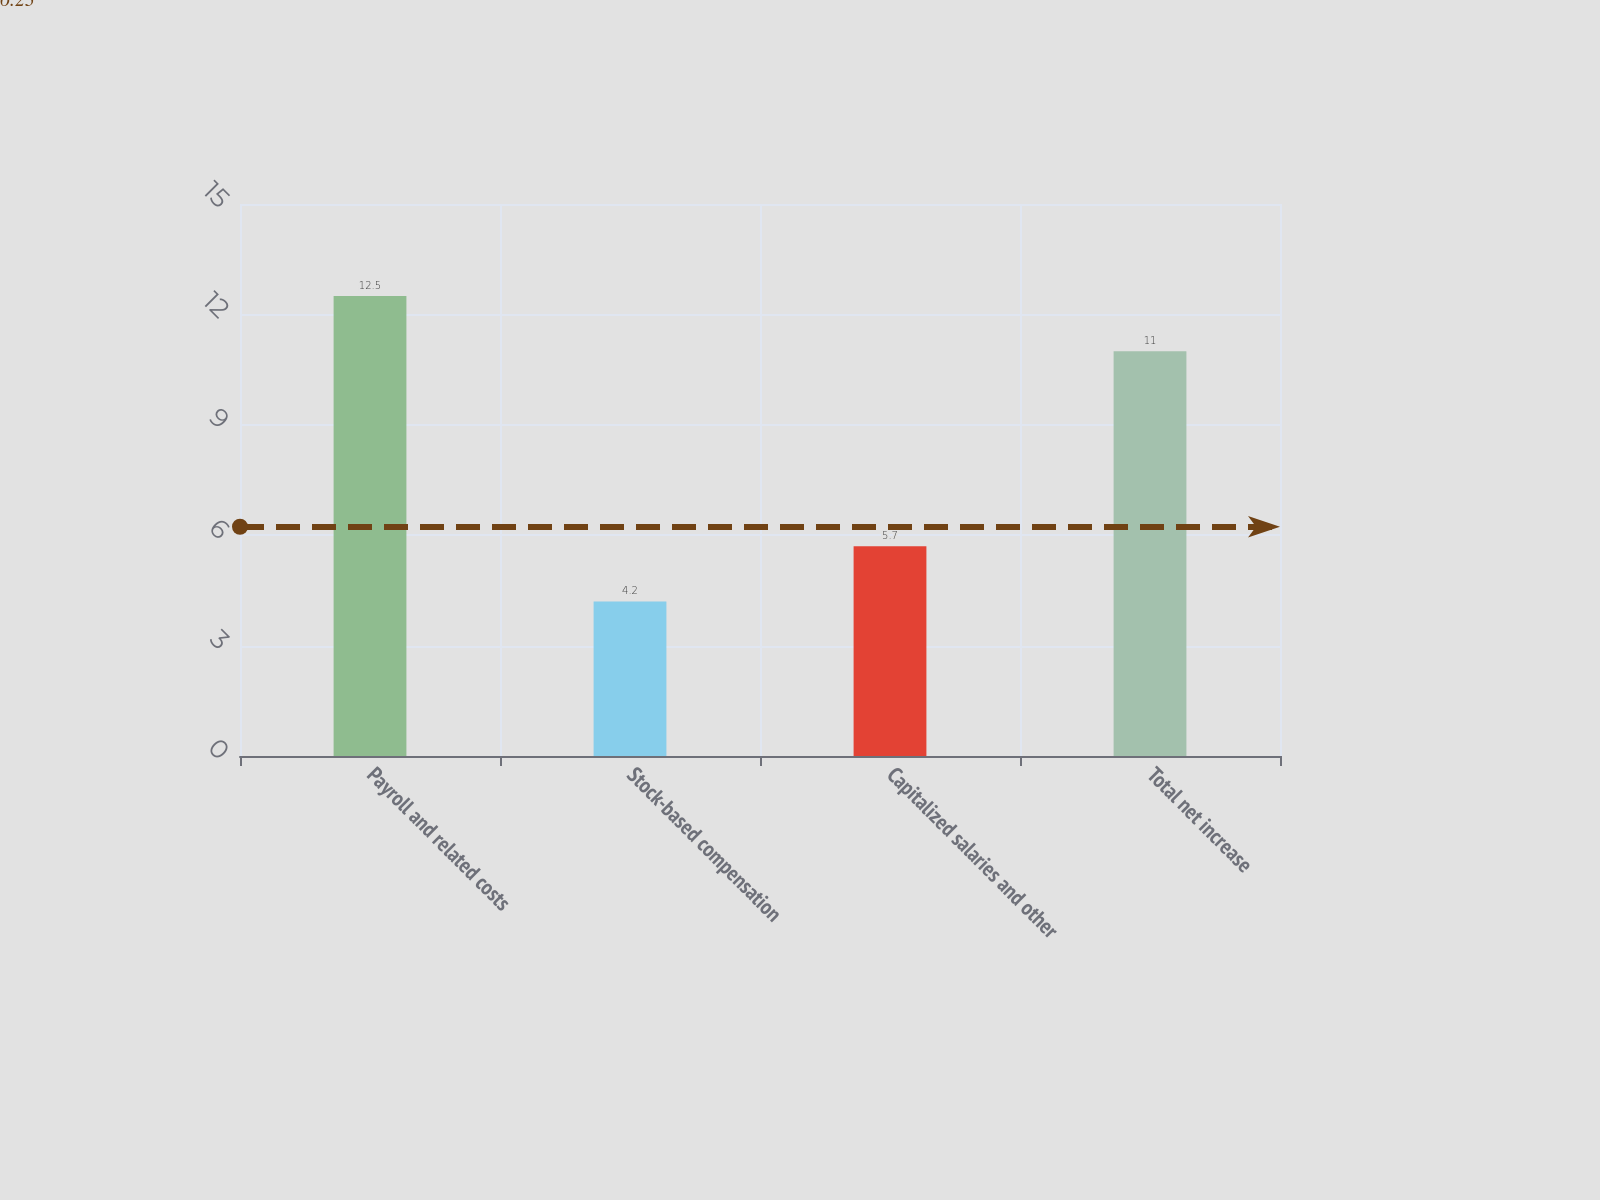Convert chart to OTSL. <chart><loc_0><loc_0><loc_500><loc_500><bar_chart><fcel>Payroll and related costs<fcel>Stock-based compensation<fcel>Capitalized salaries and other<fcel>Total net increase<nl><fcel>12.5<fcel>4.2<fcel>5.7<fcel>11<nl></chart> 